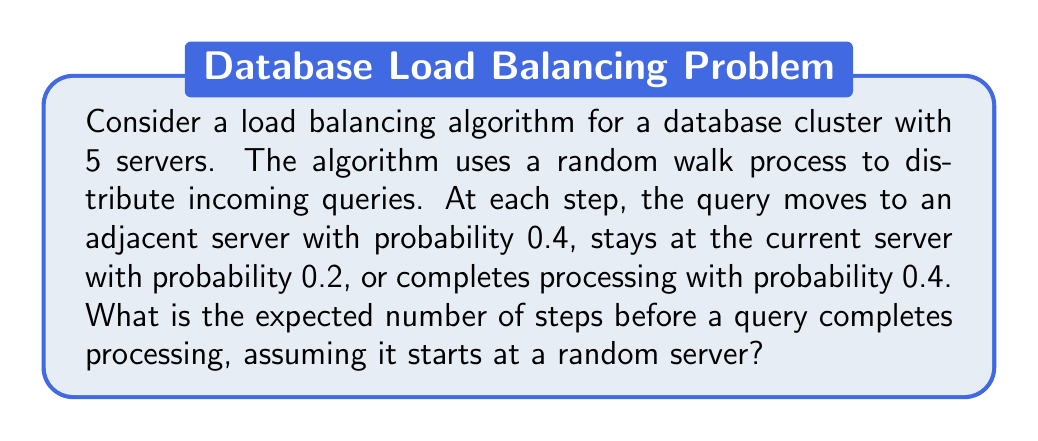Give your solution to this math problem. Let's approach this step-by-step:

1) First, we need to recognize this as an absorbing Markov chain problem. The "completion" state is the absorbing state, and each server represents a transient state.

2) Let's define our transition matrix P:

   $$P = \begin{bmatrix}
   0.2 & 0.4 & 0 & 0 & 0 & 0.4 \\
   0.2 & 0.2 & 0.2 & 0 & 0 & 0.4 \\
   0 & 0.2 & 0.2 & 0.2 & 0 & 0.4 \\
   0 & 0 & 0.2 & 0.2 & 0.2 & 0.4 \\
   0 & 0 & 0 & 0.4 & 0.2 & 0.4 \\
   0 & 0 & 0 & 0 & 0 & 1
   \end{bmatrix}$$

   Where the last row and column represent the absorbing (completion) state.

3) We need to find the fundamental matrix N:
   
   $$N = (I - Q)^{-1}$$

   Where Q is the submatrix of P without the absorbing state:

   $$Q = \begin{bmatrix}
   0.2 & 0.4 & 0 & 0 & 0 \\
   0.2 & 0.2 & 0.2 & 0 & 0 \\
   0 & 0.2 & 0.2 & 0.2 & 0 \\
   0 & 0 & 0.2 & 0.2 & 0.2 \\
   0 & 0 & 0 & 0.4 & 0.2
   \end{bmatrix}$$

4) Calculate $(I - Q)$:

   $$(I - Q) = \begin{bmatrix}
   0.8 & -0.4 & 0 & 0 & 0 \\
   -0.2 & 0.8 & -0.2 & 0 & 0 \\
   0 & -0.2 & 0.8 & -0.2 & 0 \\
   0 & 0 & -0.2 & 0.8 & -0.2 \\
   0 & 0 & 0 & -0.4 & 0.8
   \end{bmatrix}$$

5) Invert this matrix to get N. (The exact calculation is omitted for brevity, but can be done using standard matrix inversion techniques.)

6) The expected number of steps before absorption when starting in state i is given by the i-th element of the vector:

   $$t = N \cdot \mathbf{1}$$

   Where $\mathbf{1}$ is a column vector of ones.

7) After calculation, we get:

   $$t \approx \begin{bmatrix}
   2.5 \\
   2.5 \\
   2.5 \\
   2.5 \\
   2.5
   \end{bmatrix}$$

8) Since the query starts at a random server, the expected number of steps is the average of these values, which is 2.5.
Answer: 2.5 steps 